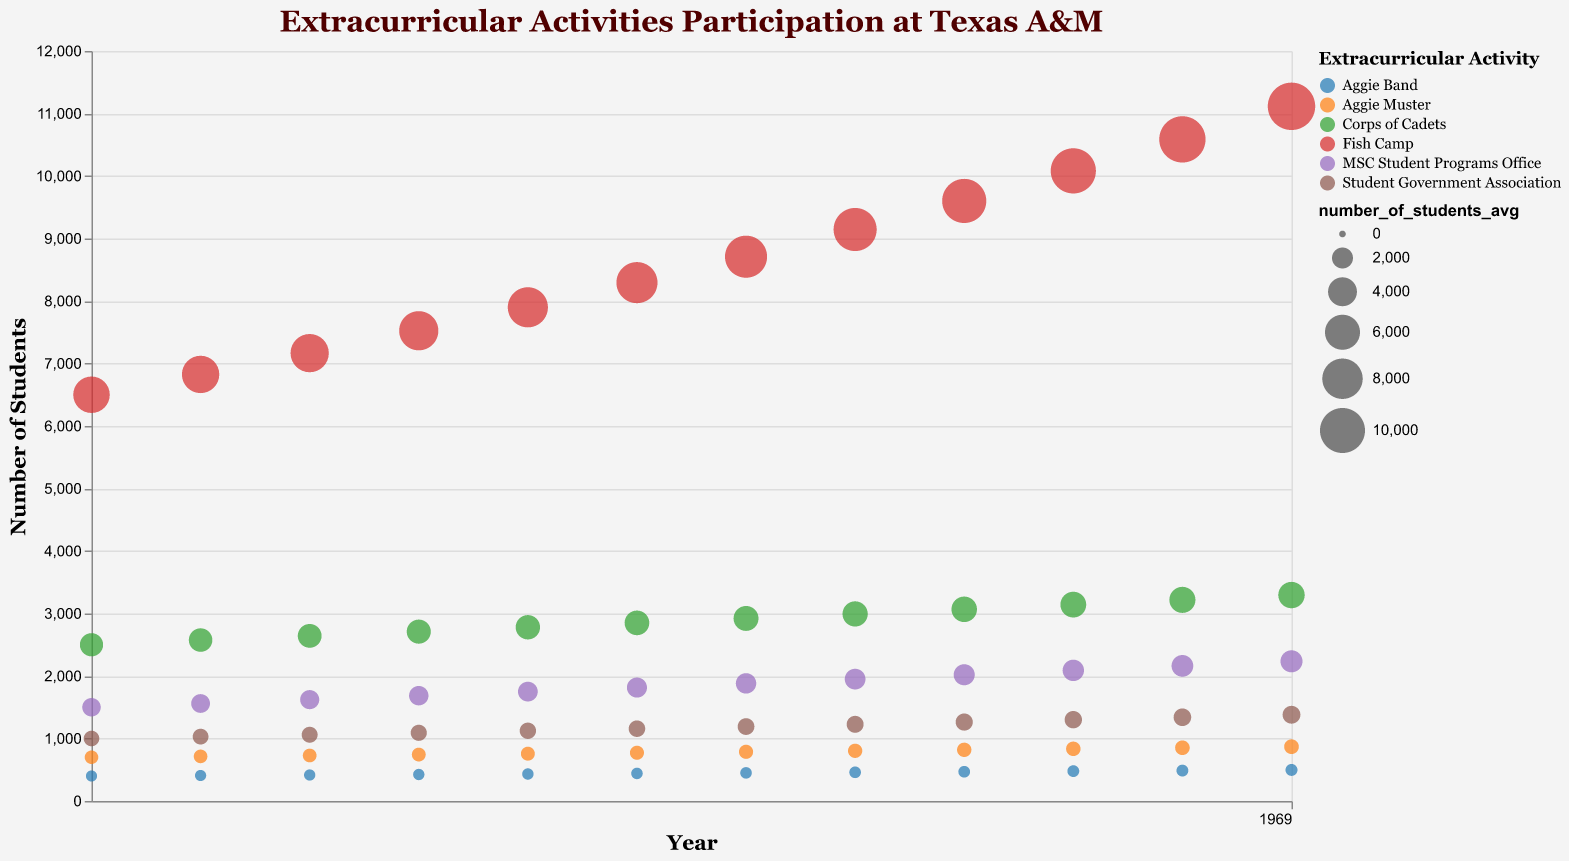Which extracurricular activity had the highest number of students on average in 2021? In 2021, the largest bubble represents the highest number of students, which belongs to Fish Camp.
Answer: Fish Camp Which extracurricular activity had the highest annual growth rate? By inspecting the tooltip information in the chart, Fish Camp has the highest annual growth rate of 5%.
Answer: Fish Camp How does the transparency affect the visibility of overlapping bubbles in this chart? The transparency in the bubbles helps to see the number of students in overlapping activities without fully obscuring one another.
Answer: Enhances visibility Which activity saw a steady annual growth rate of 3%? Noting the tooltip for the activities listed, both the Corps of Cadets and Student Government Association show a consistent 3% annual growth rate.
Answer: Corps of Cadets and Student Government Association Compare the number of students in the Aggie Band in 2010 to 2021. Which year had more students? By checking the y-axis and bubble size, Aggie Band had 400 students in 2010 compared to 497 students in 2021, indicating there were more students in 2021.
Answer: 2021 How many students participated in the MSC Student Programs Office in 2015 compared to 2020? Referring to the y-axis, in 2015, there were approximately 1815 students in the MSC Student Programs Office, and in 2020, there were approximately 2162 students.
Answer: 2162 in 2020; 1815 in 2015 What is the average number of students participating in Fish Camp between 2018 and 2020? Fish Camp had 9601 students in 2018, 10082 in 2019, and 10586 in 2020. The average is (9601 + 10082 + 10586) / 3 = 10089.67
Answer: 10089.67 Which activity had the smallest number of students on average in 2010? By observing the smallest bubble size for 2010, the Aggie Band had the lowest number of students, with 400 students.
Answer: Aggie Band 